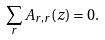<formula> <loc_0><loc_0><loc_500><loc_500>\sum _ { r } { A } _ { r , r } { \left ( z \right ) = 0 . }</formula> 